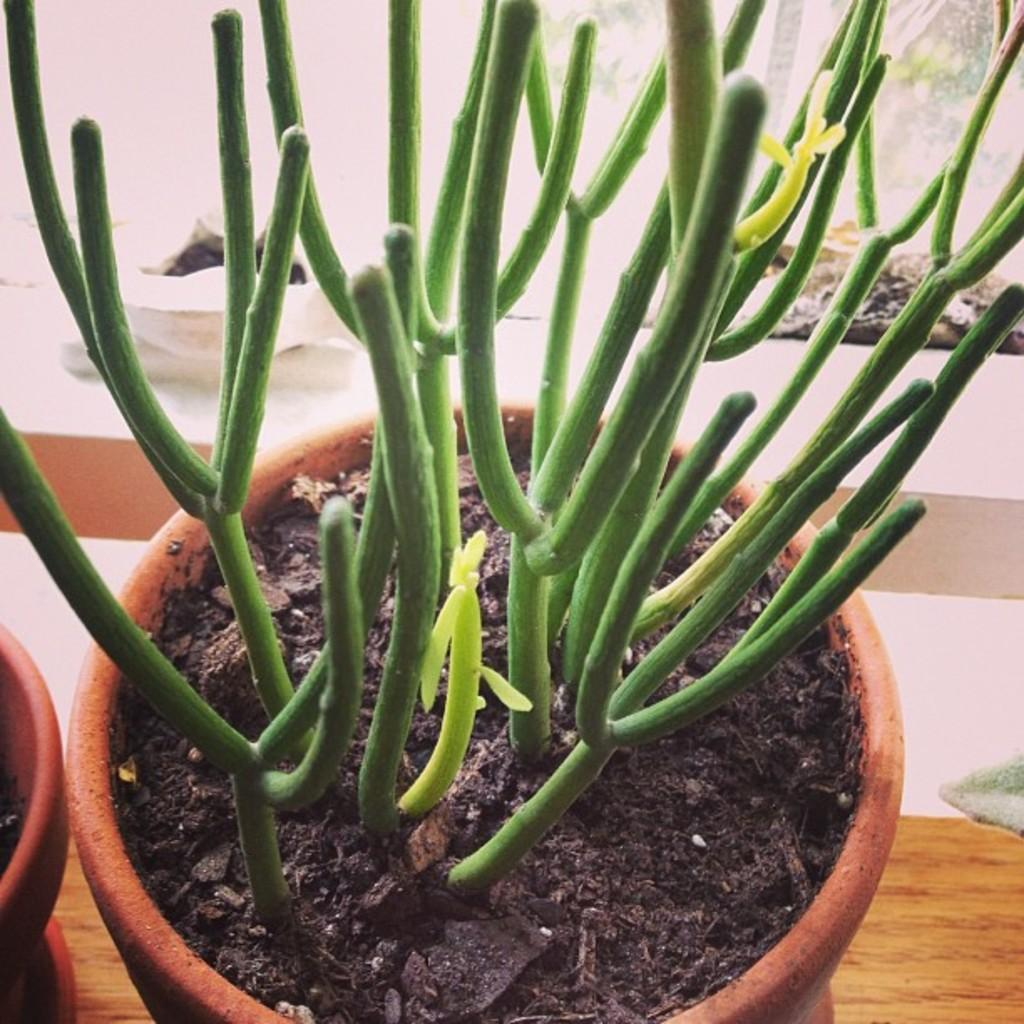What type of plant is in the pot in the image? The provided facts do not specify the type of plant in the pot. How many pots are visible in the image? There are two pots visible in the image. What type of gun is present in the image? There is no gun present in the image; it only features a plant in a pot and another pot. 